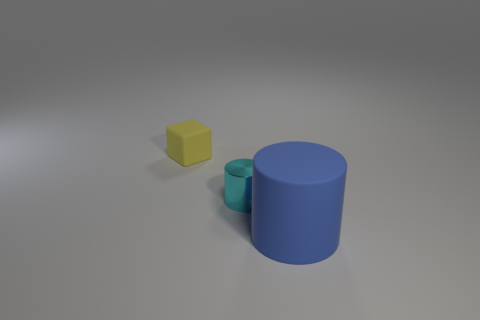Are there any yellow matte blocks of the same size as the cyan shiny object?
Provide a short and direct response. Yes. What is the material of the yellow thing that is the same size as the cyan cylinder?
Provide a short and direct response. Rubber. How many objects are either rubber cylinders to the right of the small rubber thing or cylinders that are on the left side of the large cylinder?
Your answer should be compact. 2. Is there another gray metal object of the same shape as the tiny metal object?
Provide a short and direct response. No. How many matte things are either blue spheres or big blue cylinders?
Your response must be concise. 1. What is the shape of the big blue object?
Make the answer very short. Cylinder. How many yellow things have the same material as the blue cylinder?
Your answer should be compact. 1. What color is the cylinder that is made of the same material as the yellow block?
Your answer should be compact. Blue. There is a rubber object in front of the yellow matte object; does it have the same size as the tiny metallic object?
Ensure brevity in your answer.  No. There is another object that is the same shape as the tiny metallic thing; what color is it?
Ensure brevity in your answer.  Blue. 